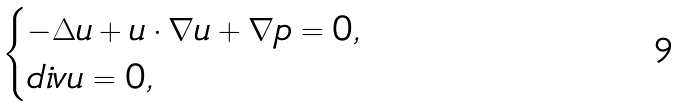Convert formula to latex. <formula><loc_0><loc_0><loc_500><loc_500>\begin{cases} - \Delta u + u \cdot \nabla u + \nabla p = 0 , \\ d i v u = 0 , \end{cases}</formula> 